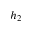Convert formula to latex. <formula><loc_0><loc_0><loc_500><loc_500>h _ { 2 }</formula> 